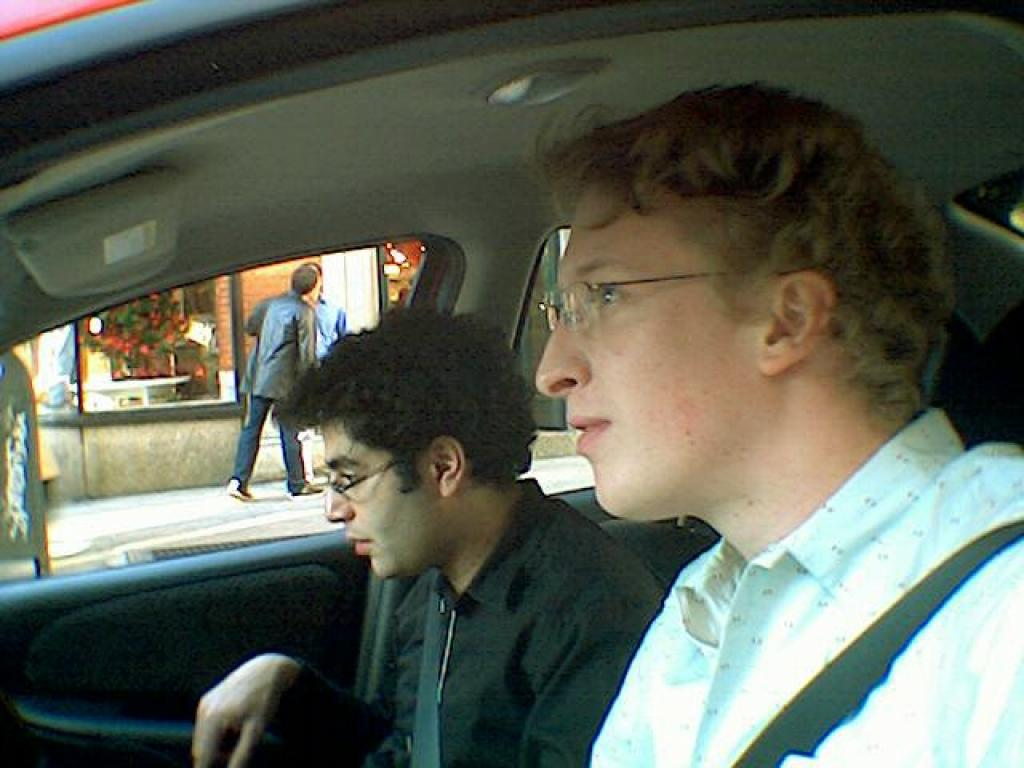How many people are present in the image? There are four persons in the image. What are two of the persons doing in the image? Two persons are sitting in a car. What are the other two persons doing in the image? The other two persons are outside the car. What can be seen in the background of the image? There is a building visible in the image. What type of crow can be seen perched on the wheel of the car in the image? There is no crow or wheel present in the image; it features a car with people inside and outside. What kind of structure is visible on top of the building in the image? There is no structure visible on top of the building in the image; only the building itself is present. 